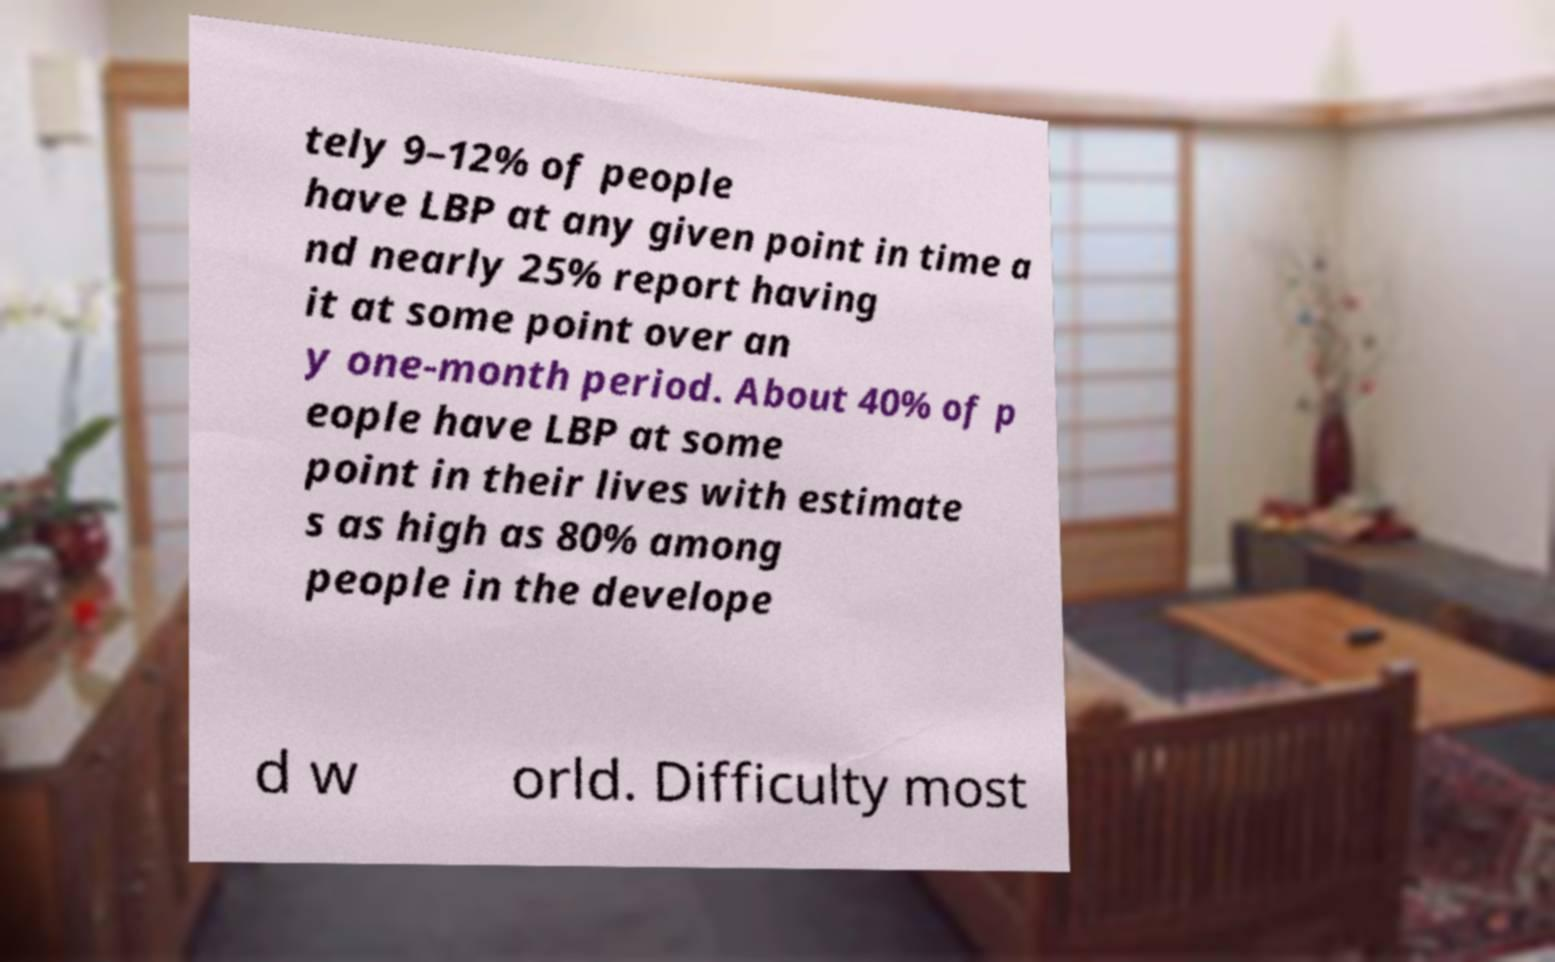Could you extract and type out the text from this image? tely 9–12% of people have LBP at any given point in time a nd nearly 25% report having it at some point over an y one-month period. About 40% of p eople have LBP at some point in their lives with estimate s as high as 80% among people in the develope d w orld. Difficulty most 